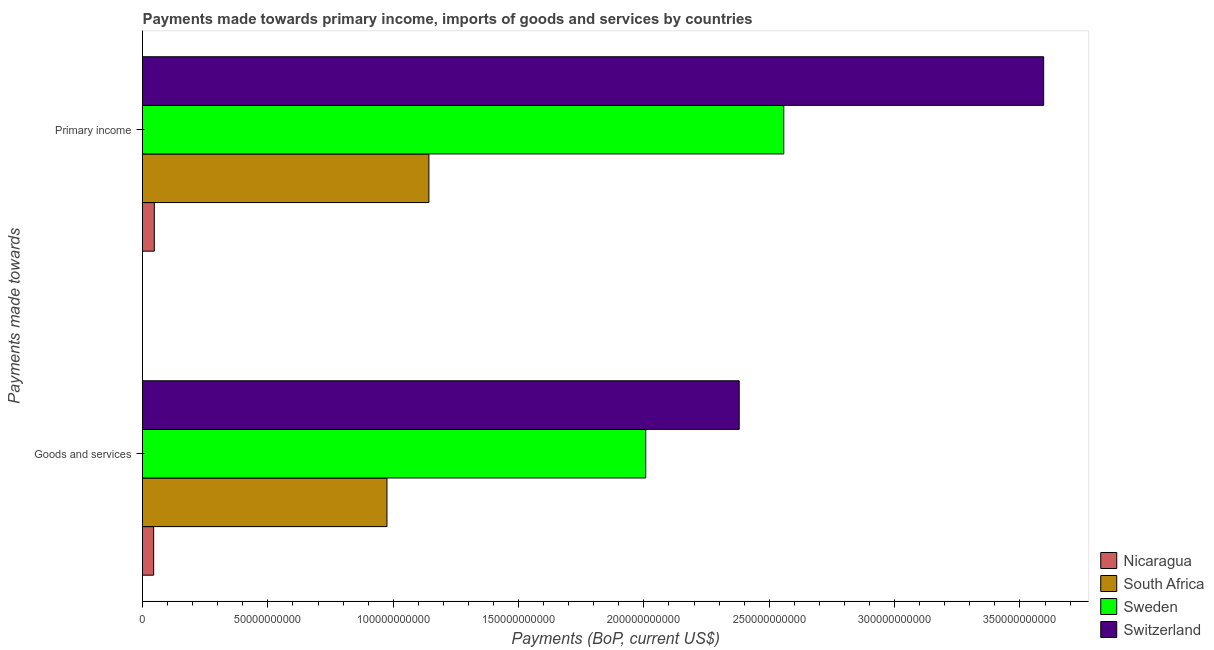How many different coloured bars are there?
Your response must be concise. 4. Are the number of bars per tick equal to the number of legend labels?
Offer a terse response. Yes. What is the label of the 2nd group of bars from the top?
Your response must be concise. Goods and services. What is the payments made towards primary income in Switzerland?
Your answer should be very brief. 3.59e+11. Across all countries, what is the maximum payments made towards goods and services?
Your response must be concise. 2.38e+11. Across all countries, what is the minimum payments made towards primary income?
Your answer should be very brief. 4.71e+09. In which country was the payments made towards primary income maximum?
Offer a very short reply. Switzerland. In which country was the payments made towards goods and services minimum?
Your response must be concise. Nicaragua. What is the total payments made towards primary income in the graph?
Offer a terse response. 7.34e+11. What is the difference between the payments made towards goods and services in Switzerland and that in South Africa?
Ensure brevity in your answer.  1.41e+11. What is the difference between the payments made towards primary income in South Africa and the payments made towards goods and services in Nicaragua?
Your response must be concise. 1.10e+11. What is the average payments made towards goods and services per country?
Give a very brief answer. 1.35e+11. What is the difference between the payments made towards goods and services and payments made towards primary income in Switzerland?
Ensure brevity in your answer.  -1.21e+11. In how many countries, is the payments made towards goods and services greater than 320000000000 US$?
Offer a very short reply. 0. What is the ratio of the payments made towards primary income in South Africa to that in Nicaragua?
Provide a succinct answer. 24.24. Is the payments made towards primary income in South Africa less than that in Nicaragua?
Make the answer very short. No. In how many countries, is the payments made towards goods and services greater than the average payments made towards goods and services taken over all countries?
Your response must be concise. 2. What does the 3rd bar from the top in Primary income represents?
Offer a very short reply. South Africa. What does the 4th bar from the bottom in Primary income represents?
Your answer should be very brief. Switzerland. How many bars are there?
Make the answer very short. 8. Are all the bars in the graph horizontal?
Provide a succinct answer. Yes. How many countries are there in the graph?
Provide a short and direct response. 4. What is the difference between two consecutive major ticks on the X-axis?
Provide a succinct answer. 5.00e+1. Are the values on the major ticks of X-axis written in scientific E-notation?
Offer a very short reply. No. Does the graph contain grids?
Your answer should be very brief. No. Where does the legend appear in the graph?
Make the answer very short. Bottom right. What is the title of the graph?
Your answer should be very brief. Payments made towards primary income, imports of goods and services by countries. What is the label or title of the X-axis?
Keep it short and to the point. Payments (BoP, current US$). What is the label or title of the Y-axis?
Offer a terse response. Payments made towards. What is the Payments (BoP, current US$) of Nicaragua in Goods and services?
Your answer should be very brief. 4.45e+09. What is the Payments (BoP, current US$) of South Africa in Goods and services?
Make the answer very short. 9.75e+1. What is the Payments (BoP, current US$) of Sweden in Goods and services?
Give a very brief answer. 2.01e+11. What is the Payments (BoP, current US$) of Switzerland in Goods and services?
Offer a terse response. 2.38e+11. What is the Payments (BoP, current US$) in Nicaragua in Primary income?
Provide a succinct answer. 4.71e+09. What is the Payments (BoP, current US$) in South Africa in Primary income?
Give a very brief answer. 1.14e+11. What is the Payments (BoP, current US$) in Sweden in Primary income?
Your response must be concise. 2.56e+11. What is the Payments (BoP, current US$) of Switzerland in Primary income?
Provide a short and direct response. 3.59e+11. Across all Payments made towards, what is the maximum Payments (BoP, current US$) of Nicaragua?
Provide a succinct answer. 4.71e+09. Across all Payments made towards, what is the maximum Payments (BoP, current US$) in South Africa?
Offer a terse response. 1.14e+11. Across all Payments made towards, what is the maximum Payments (BoP, current US$) in Sweden?
Your answer should be very brief. 2.56e+11. Across all Payments made towards, what is the maximum Payments (BoP, current US$) in Switzerland?
Ensure brevity in your answer.  3.59e+11. Across all Payments made towards, what is the minimum Payments (BoP, current US$) of Nicaragua?
Provide a short and direct response. 4.45e+09. Across all Payments made towards, what is the minimum Payments (BoP, current US$) in South Africa?
Give a very brief answer. 9.75e+1. Across all Payments made towards, what is the minimum Payments (BoP, current US$) in Sweden?
Your response must be concise. 2.01e+11. Across all Payments made towards, what is the minimum Payments (BoP, current US$) of Switzerland?
Offer a very short reply. 2.38e+11. What is the total Payments (BoP, current US$) in Nicaragua in the graph?
Offer a very short reply. 9.16e+09. What is the total Payments (BoP, current US$) of South Africa in the graph?
Offer a very short reply. 2.12e+11. What is the total Payments (BoP, current US$) of Sweden in the graph?
Ensure brevity in your answer.  4.57e+11. What is the total Payments (BoP, current US$) of Switzerland in the graph?
Offer a terse response. 5.97e+11. What is the difference between the Payments (BoP, current US$) in Nicaragua in Goods and services and that in Primary income?
Provide a succinct answer. -2.61e+08. What is the difference between the Payments (BoP, current US$) of South Africa in Goods and services and that in Primary income?
Your answer should be very brief. -1.67e+1. What is the difference between the Payments (BoP, current US$) of Sweden in Goods and services and that in Primary income?
Keep it short and to the point. -5.51e+1. What is the difference between the Payments (BoP, current US$) of Switzerland in Goods and services and that in Primary income?
Your response must be concise. -1.21e+11. What is the difference between the Payments (BoP, current US$) of Nicaragua in Goods and services and the Payments (BoP, current US$) of South Africa in Primary income?
Your response must be concise. -1.10e+11. What is the difference between the Payments (BoP, current US$) of Nicaragua in Goods and services and the Payments (BoP, current US$) of Sweden in Primary income?
Keep it short and to the point. -2.51e+11. What is the difference between the Payments (BoP, current US$) of Nicaragua in Goods and services and the Payments (BoP, current US$) of Switzerland in Primary income?
Provide a succinct answer. -3.55e+11. What is the difference between the Payments (BoP, current US$) in South Africa in Goods and services and the Payments (BoP, current US$) in Sweden in Primary income?
Your answer should be very brief. -1.58e+11. What is the difference between the Payments (BoP, current US$) in South Africa in Goods and services and the Payments (BoP, current US$) in Switzerland in Primary income?
Make the answer very short. -2.62e+11. What is the difference between the Payments (BoP, current US$) in Sweden in Goods and services and the Payments (BoP, current US$) in Switzerland in Primary income?
Provide a succinct answer. -1.59e+11. What is the average Payments (BoP, current US$) in Nicaragua per Payments made towards?
Provide a short and direct response. 4.58e+09. What is the average Payments (BoP, current US$) in South Africa per Payments made towards?
Give a very brief answer. 1.06e+11. What is the average Payments (BoP, current US$) in Sweden per Payments made towards?
Offer a very short reply. 2.28e+11. What is the average Payments (BoP, current US$) in Switzerland per Payments made towards?
Provide a succinct answer. 2.99e+11. What is the difference between the Payments (BoP, current US$) in Nicaragua and Payments (BoP, current US$) in South Africa in Goods and services?
Offer a very short reply. -9.31e+1. What is the difference between the Payments (BoP, current US$) in Nicaragua and Payments (BoP, current US$) in Sweden in Goods and services?
Make the answer very short. -1.96e+11. What is the difference between the Payments (BoP, current US$) in Nicaragua and Payments (BoP, current US$) in Switzerland in Goods and services?
Give a very brief answer. -2.34e+11. What is the difference between the Payments (BoP, current US$) of South Africa and Payments (BoP, current US$) of Sweden in Goods and services?
Provide a succinct answer. -1.03e+11. What is the difference between the Payments (BoP, current US$) of South Africa and Payments (BoP, current US$) of Switzerland in Goods and services?
Ensure brevity in your answer.  -1.41e+11. What is the difference between the Payments (BoP, current US$) in Sweden and Payments (BoP, current US$) in Switzerland in Goods and services?
Make the answer very short. -3.73e+1. What is the difference between the Payments (BoP, current US$) in Nicaragua and Payments (BoP, current US$) in South Africa in Primary income?
Provide a succinct answer. -1.10e+11. What is the difference between the Payments (BoP, current US$) of Nicaragua and Payments (BoP, current US$) of Sweden in Primary income?
Give a very brief answer. -2.51e+11. What is the difference between the Payments (BoP, current US$) of Nicaragua and Payments (BoP, current US$) of Switzerland in Primary income?
Provide a succinct answer. -3.55e+11. What is the difference between the Payments (BoP, current US$) of South Africa and Payments (BoP, current US$) of Sweden in Primary income?
Your answer should be very brief. -1.42e+11. What is the difference between the Payments (BoP, current US$) in South Africa and Payments (BoP, current US$) in Switzerland in Primary income?
Your answer should be compact. -2.45e+11. What is the difference between the Payments (BoP, current US$) of Sweden and Payments (BoP, current US$) of Switzerland in Primary income?
Offer a very short reply. -1.04e+11. What is the ratio of the Payments (BoP, current US$) in Nicaragua in Goods and services to that in Primary income?
Provide a short and direct response. 0.94. What is the ratio of the Payments (BoP, current US$) of South Africa in Goods and services to that in Primary income?
Your response must be concise. 0.85. What is the ratio of the Payments (BoP, current US$) in Sweden in Goods and services to that in Primary income?
Your answer should be very brief. 0.78. What is the ratio of the Payments (BoP, current US$) of Switzerland in Goods and services to that in Primary income?
Your answer should be very brief. 0.66. What is the difference between the highest and the second highest Payments (BoP, current US$) of Nicaragua?
Your answer should be compact. 2.61e+08. What is the difference between the highest and the second highest Payments (BoP, current US$) in South Africa?
Ensure brevity in your answer.  1.67e+1. What is the difference between the highest and the second highest Payments (BoP, current US$) of Sweden?
Give a very brief answer. 5.51e+1. What is the difference between the highest and the second highest Payments (BoP, current US$) of Switzerland?
Offer a terse response. 1.21e+11. What is the difference between the highest and the lowest Payments (BoP, current US$) in Nicaragua?
Offer a very short reply. 2.61e+08. What is the difference between the highest and the lowest Payments (BoP, current US$) of South Africa?
Provide a short and direct response. 1.67e+1. What is the difference between the highest and the lowest Payments (BoP, current US$) in Sweden?
Offer a terse response. 5.51e+1. What is the difference between the highest and the lowest Payments (BoP, current US$) of Switzerland?
Your answer should be very brief. 1.21e+11. 